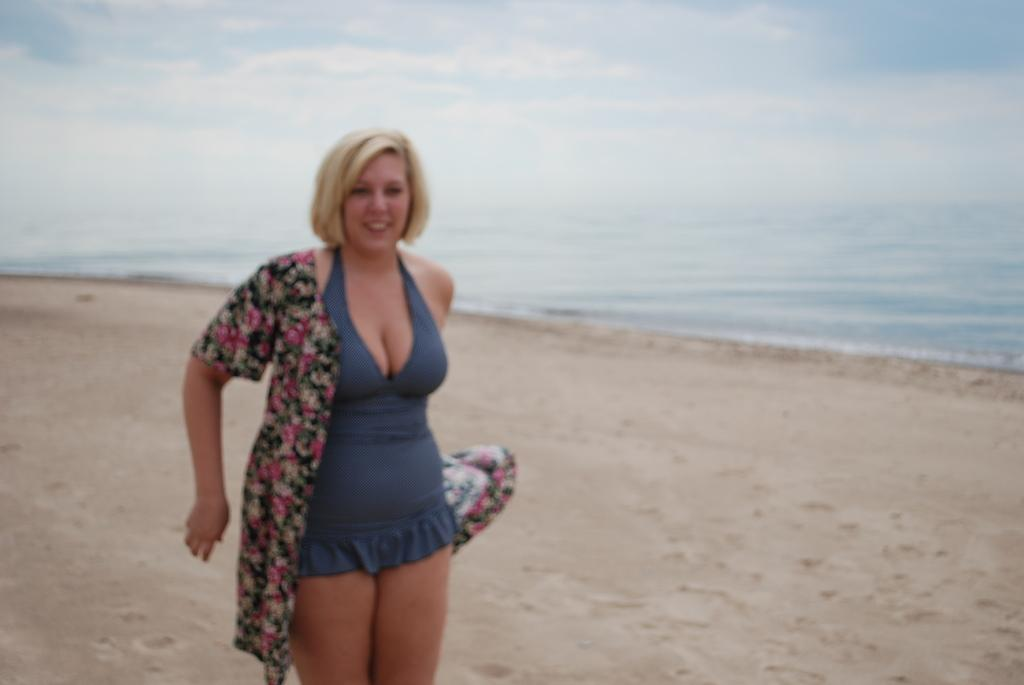What is the person in the image wearing? There is a person with a dress in the image. Where is the person standing? The person is standing on the sand. What can be seen in the background of the image? There is water, clouds, and the sky visible in the background of the image. How many snakes are slithering on the sand in the image? There are no snakes visible in the image; the person is standing on the sand. What is the record for the longest dress worn by a person on the beach? The image does not provide information about any records, and there is no mention of a dress's length. 